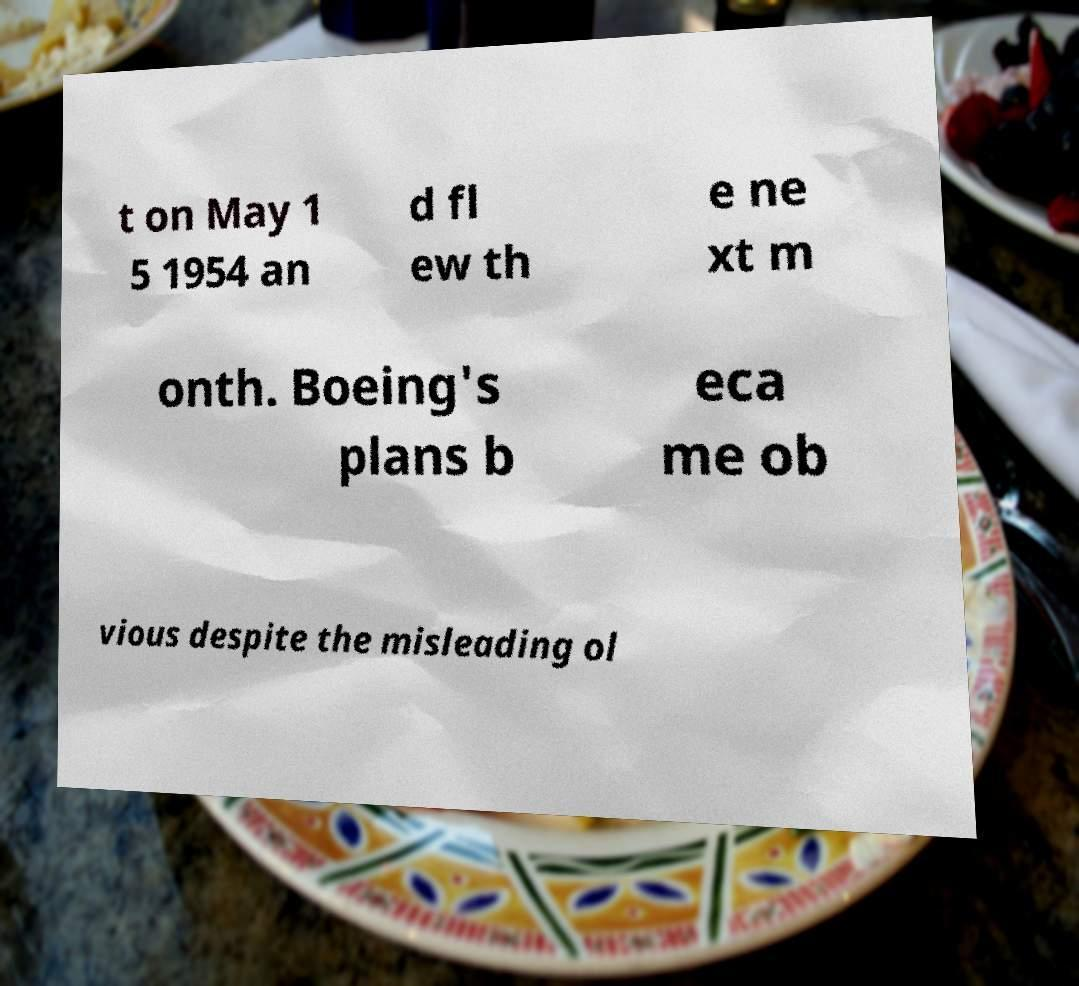I need the written content from this picture converted into text. Can you do that? t on May 1 5 1954 an d fl ew th e ne xt m onth. Boeing's plans b eca me ob vious despite the misleading ol 